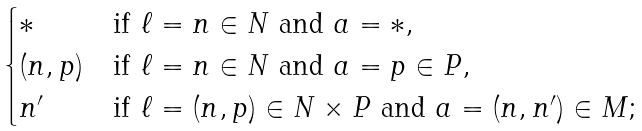Convert formula to latex. <formula><loc_0><loc_0><loc_500><loc_500>\begin{cases} * & \text {if $\ell = n \in N$ and $a = *$} , \\ ( n , p ) & \text {if $\ell = n \in N$ and $a = p \in P$} , \\ n ^ { \prime } & \text {if $\ell = (n, p) \in N \times P$ and     $a = (n, n^{\prime}) \in M$} ; \end{cases}</formula> 